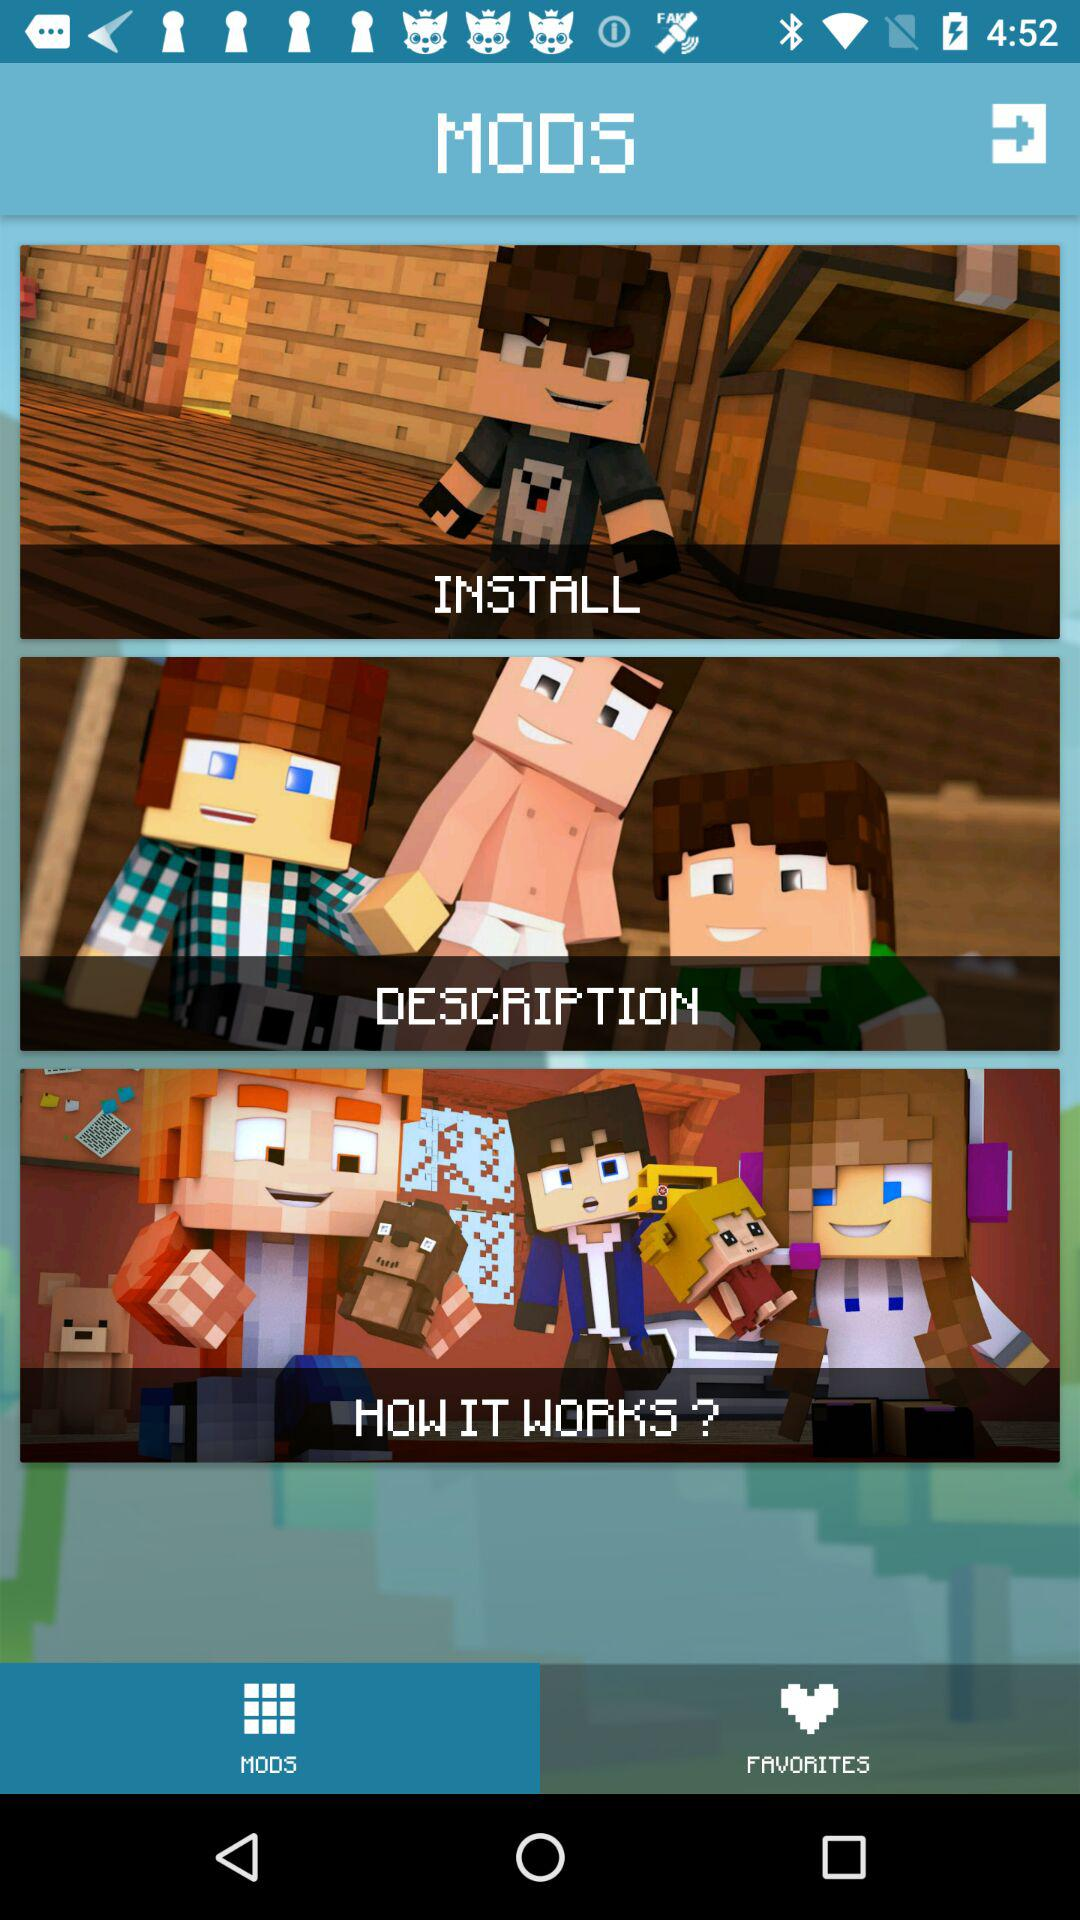Which option is selected? The selected option is "MODS". 